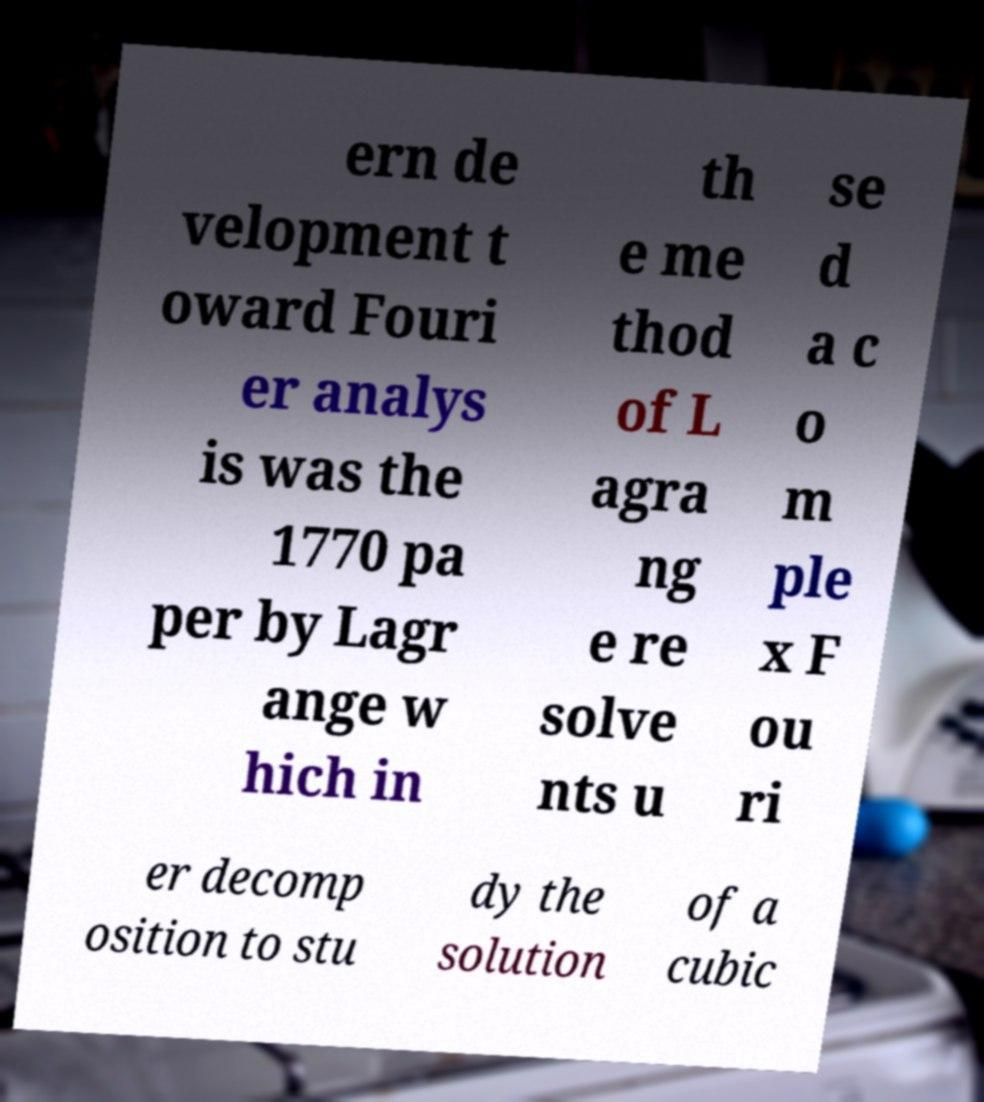For documentation purposes, I need the text within this image transcribed. Could you provide that? ern de velopment t oward Fouri er analys is was the 1770 pa per by Lagr ange w hich in th e me thod of L agra ng e re solve nts u se d a c o m ple x F ou ri er decomp osition to stu dy the solution of a cubic 